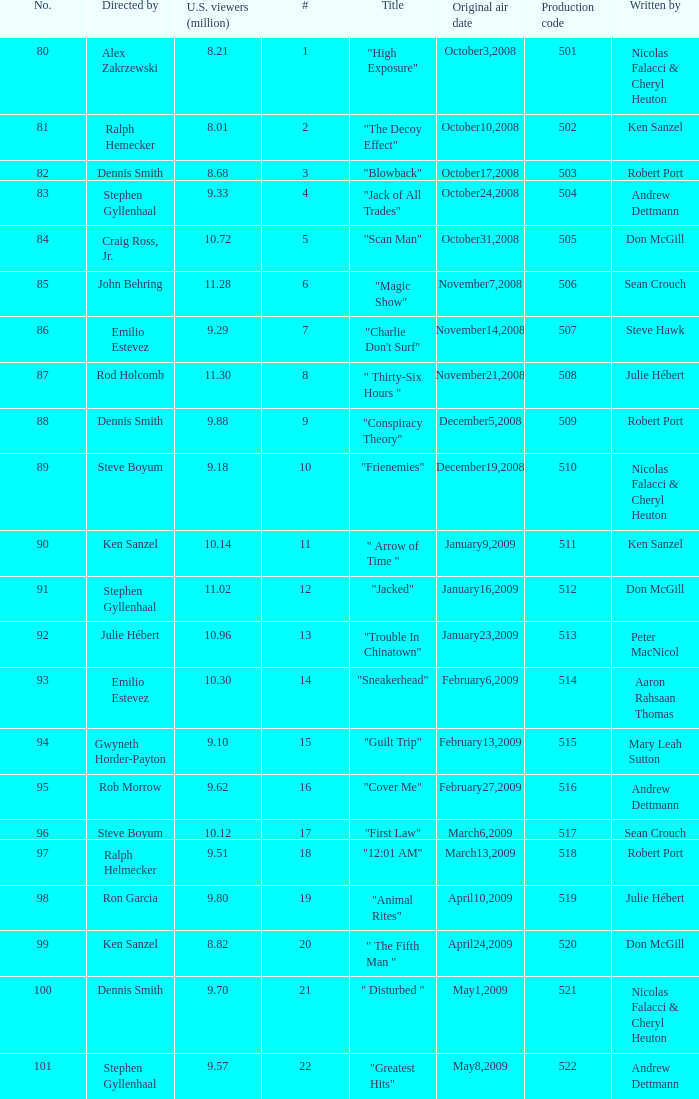What episode had 10.14 million viewers (U.S.)? 11.0. 